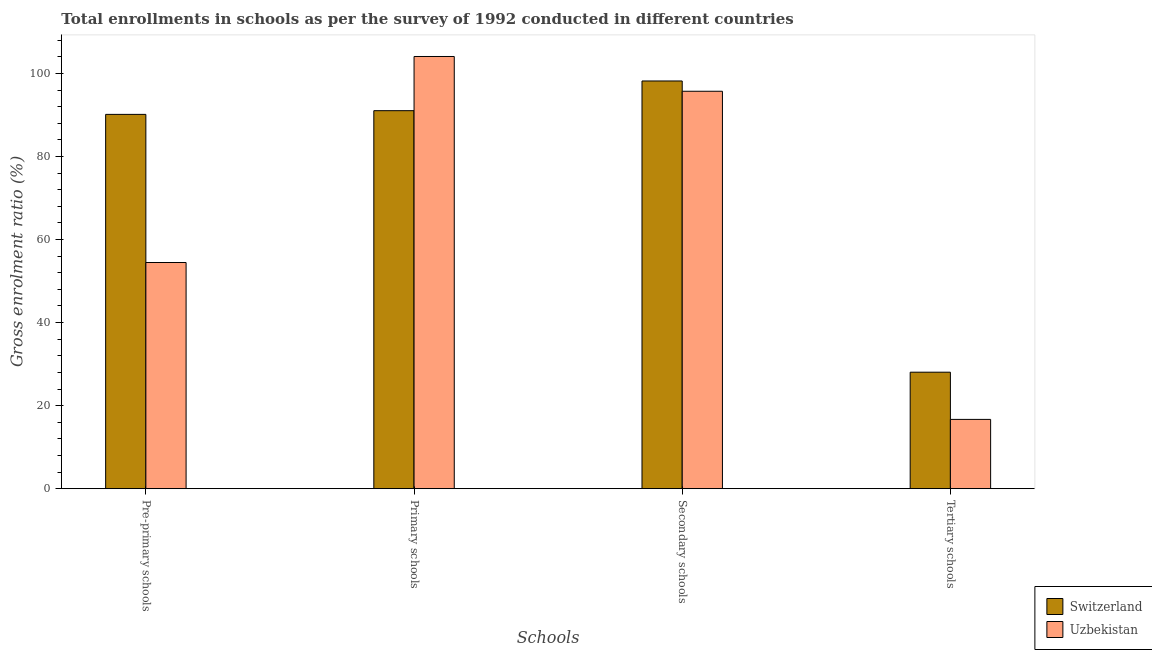How many bars are there on the 2nd tick from the left?
Ensure brevity in your answer.  2. What is the label of the 2nd group of bars from the left?
Your answer should be very brief. Primary schools. What is the gross enrolment ratio in secondary schools in Switzerland?
Keep it short and to the point. 98.2. Across all countries, what is the maximum gross enrolment ratio in primary schools?
Give a very brief answer. 104.1. Across all countries, what is the minimum gross enrolment ratio in primary schools?
Offer a very short reply. 91.04. In which country was the gross enrolment ratio in primary schools maximum?
Offer a terse response. Uzbekistan. In which country was the gross enrolment ratio in pre-primary schools minimum?
Provide a short and direct response. Uzbekistan. What is the total gross enrolment ratio in primary schools in the graph?
Keep it short and to the point. 195.14. What is the difference between the gross enrolment ratio in tertiary schools in Switzerland and that in Uzbekistan?
Your response must be concise. 11.37. What is the difference between the gross enrolment ratio in tertiary schools in Uzbekistan and the gross enrolment ratio in secondary schools in Switzerland?
Your response must be concise. -81.51. What is the average gross enrolment ratio in tertiary schools per country?
Offer a very short reply. 22.37. What is the difference between the gross enrolment ratio in secondary schools and gross enrolment ratio in pre-primary schools in Uzbekistan?
Keep it short and to the point. 41.25. In how many countries, is the gross enrolment ratio in secondary schools greater than 104 %?
Make the answer very short. 0. What is the ratio of the gross enrolment ratio in primary schools in Uzbekistan to that in Switzerland?
Offer a terse response. 1.14. Is the gross enrolment ratio in pre-primary schools in Switzerland less than that in Uzbekistan?
Give a very brief answer. No. What is the difference between the highest and the second highest gross enrolment ratio in primary schools?
Make the answer very short. 13.05. What is the difference between the highest and the lowest gross enrolment ratio in secondary schools?
Your response must be concise. 2.48. Is the sum of the gross enrolment ratio in secondary schools in Switzerland and Uzbekistan greater than the maximum gross enrolment ratio in pre-primary schools across all countries?
Keep it short and to the point. Yes. What does the 1st bar from the left in Pre-primary schools represents?
Offer a very short reply. Switzerland. What does the 1st bar from the right in Primary schools represents?
Your answer should be compact. Uzbekistan. How many bars are there?
Your response must be concise. 8. Are all the bars in the graph horizontal?
Offer a very short reply. No. How many countries are there in the graph?
Your response must be concise. 2. Does the graph contain any zero values?
Your answer should be compact. No. Does the graph contain grids?
Provide a succinct answer. No. How many legend labels are there?
Offer a terse response. 2. What is the title of the graph?
Make the answer very short. Total enrollments in schools as per the survey of 1992 conducted in different countries. Does "Algeria" appear as one of the legend labels in the graph?
Provide a short and direct response. No. What is the label or title of the X-axis?
Give a very brief answer. Schools. What is the Gross enrolment ratio (%) in Switzerland in Pre-primary schools?
Offer a very short reply. 90.15. What is the Gross enrolment ratio (%) in Uzbekistan in Pre-primary schools?
Offer a very short reply. 54.47. What is the Gross enrolment ratio (%) in Switzerland in Primary schools?
Make the answer very short. 91.04. What is the Gross enrolment ratio (%) of Uzbekistan in Primary schools?
Offer a terse response. 104.1. What is the Gross enrolment ratio (%) in Switzerland in Secondary schools?
Your answer should be very brief. 98.2. What is the Gross enrolment ratio (%) of Uzbekistan in Secondary schools?
Your response must be concise. 95.72. What is the Gross enrolment ratio (%) of Switzerland in Tertiary schools?
Offer a very short reply. 28.06. What is the Gross enrolment ratio (%) of Uzbekistan in Tertiary schools?
Provide a short and direct response. 16.69. Across all Schools, what is the maximum Gross enrolment ratio (%) of Switzerland?
Make the answer very short. 98.2. Across all Schools, what is the maximum Gross enrolment ratio (%) of Uzbekistan?
Your answer should be very brief. 104.1. Across all Schools, what is the minimum Gross enrolment ratio (%) in Switzerland?
Give a very brief answer. 28.06. Across all Schools, what is the minimum Gross enrolment ratio (%) of Uzbekistan?
Provide a short and direct response. 16.69. What is the total Gross enrolment ratio (%) of Switzerland in the graph?
Make the answer very short. 307.45. What is the total Gross enrolment ratio (%) in Uzbekistan in the graph?
Provide a short and direct response. 270.97. What is the difference between the Gross enrolment ratio (%) of Switzerland in Pre-primary schools and that in Primary schools?
Provide a succinct answer. -0.89. What is the difference between the Gross enrolment ratio (%) of Uzbekistan in Pre-primary schools and that in Primary schools?
Provide a short and direct response. -49.62. What is the difference between the Gross enrolment ratio (%) of Switzerland in Pre-primary schools and that in Secondary schools?
Give a very brief answer. -8.05. What is the difference between the Gross enrolment ratio (%) in Uzbekistan in Pre-primary schools and that in Secondary schools?
Your response must be concise. -41.25. What is the difference between the Gross enrolment ratio (%) of Switzerland in Pre-primary schools and that in Tertiary schools?
Ensure brevity in your answer.  62.09. What is the difference between the Gross enrolment ratio (%) of Uzbekistan in Pre-primary schools and that in Tertiary schools?
Keep it short and to the point. 37.79. What is the difference between the Gross enrolment ratio (%) in Switzerland in Primary schools and that in Secondary schools?
Give a very brief answer. -7.15. What is the difference between the Gross enrolment ratio (%) of Uzbekistan in Primary schools and that in Secondary schools?
Offer a terse response. 8.38. What is the difference between the Gross enrolment ratio (%) of Switzerland in Primary schools and that in Tertiary schools?
Offer a very short reply. 62.99. What is the difference between the Gross enrolment ratio (%) in Uzbekistan in Primary schools and that in Tertiary schools?
Provide a succinct answer. 87.41. What is the difference between the Gross enrolment ratio (%) in Switzerland in Secondary schools and that in Tertiary schools?
Offer a terse response. 70.14. What is the difference between the Gross enrolment ratio (%) of Uzbekistan in Secondary schools and that in Tertiary schools?
Ensure brevity in your answer.  79.03. What is the difference between the Gross enrolment ratio (%) in Switzerland in Pre-primary schools and the Gross enrolment ratio (%) in Uzbekistan in Primary schools?
Make the answer very short. -13.95. What is the difference between the Gross enrolment ratio (%) in Switzerland in Pre-primary schools and the Gross enrolment ratio (%) in Uzbekistan in Secondary schools?
Provide a succinct answer. -5.57. What is the difference between the Gross enrolment ratio (%) of Switzerland in Pre-primary schools and the Gross enrolment ratio (%) of Uzbekistan in Tertiary schools?
Your answer should be very brief. 73.46. What is the difference between the Gross enrolment ratio (%) in Switzerland in Primary schools and the Gross enrolment ratio (%) in Uzbekistan in Secondary schools?
Ensure brevity in your answer.  -4.68. What is the difference between the Gross enrolment ratio (%) of Switzerland in Primary schools and the Gross enrolment ratio (%) of Uzbekistan in Tertiary schools?
Offer a very short reply. 74.36. What is the difference between the Gross enrolment ratio (%) in Switzerland in Secondary schools and the Gross enrolment ratio (%) in Uzbekistan in Tertiary schools?
Ensure brevity in your answer.  81.51. What is the average Gross enrolment ratio (%) in Switzerland per Schools?
Offer a very short reply. 76.86. What is the average Gross enrolment ratio (%) in Uzbekistan per Schools?
Provide a short and direct response. 67.74. What is the difference between the Gross enrolment ratio (%) of Switzerland and Gross enrolment ratio (%) of Uzbekistan in Pre-primary schools?
Give a very brief answer. 35.68. What is the difference between the Gross enrolment ratio (%) of Switzerland and Gross enrolment ratio (%) of Uzbekistan in Primary schools?
Your answer should be compact. -13.05. What is the difference between the Gross enrolment ratio (%) in Switzerland and Gross enrolment ratio (%) in Uzbekistan in Secondary schools?
Your answer should be very brief. 2.48. What is the difference between the Gross enrolment ratio (%) in Switzerland and Gross enrolment ratio (%) in Uzbekistan in Tertiary schools?
Provide a succinct answer. 11.37. What is the ratio of the Gross enrolment ratio (%) in Switzerland in Pre-primary schools to that in Primary schools?
Provide a short and direct response. 0.99. What is the ratio of the Gross enrolment ratio (%) of Uzbekistan in Pre-primary schools to that in Primary schools?
Offer a very short reply. 0.52. What is the ratio of the Gross enrolment ratio (%) of Switzerland in Pre-primary schools to that in Secondary schools?
Offer a terse response. 0.92. What is the ratio of the Gross enrolment ratio (%) in Uzbekistan in Pre-primary schools to that in Secondary schools?
Keep it short and to the point. 0.57. What is the ratio of the Gross enrolment ratio (%) of Switzerland in Pre-primary schools to that in Tertiary schools?
Provide a short and direct response. 3.21. What is the ratio of the Gross enrolment ratio (%) in Uzbekistan in Pre-primary schools to that in Tertiary schools?
Your response must be concise. 3.26. What is the ratio of the Gross enrolment ratio (%) of Switzerland in Primary schools to that in Secondary schools?
Give a very brief answer. 0.93. What is the ratio of the Gross enrolment ratio (%) of Uzbekistan in Primary schools to that in Secondary schools?
Make the answer very short. 1.09. What is the ratio of the Gross enrolment ratio (%) of Switzerland in Primary schools to that in Tertiary schools?
Give a very brief answer. 3.25. What is the ratio of the Gross enrolment ratio (%) of Uzbekistan in Primary schools to that in Tertiary schools?
Make the answer very short. 6.24. What is the ratio of the Gross enrolment ratio (%) of Uzbekistan in Secondary schools to that in Tertiary schools?
Ensure brevity in your answer.  5.74. What is the difference between the highest and the second highest Gross enrolment ratio (%) in Switzerland?
Ensure brevity in your answer.  7.15. What is the difference between the highest and the second highest Gross enrolment ratio (%) of Uzbekistan?
Make the answer very short. 8.38. What is the difference between the highest and the lowest Gross enrolment ratio (%) in Switzerland?
Ensure brevity in your answer.  70.14. What is the difference between the highest and the lowest Gross enrolment ratio (%) in Uzbekistan?
Provide a short and direct response. 87.41. 